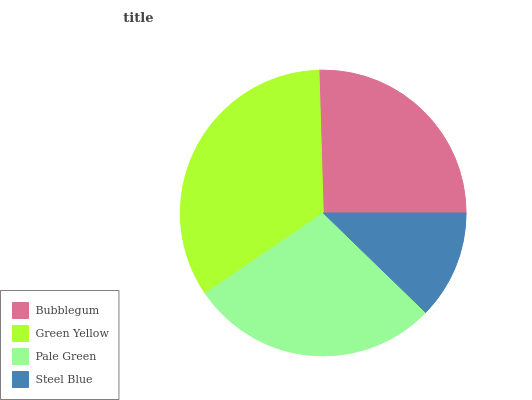Is Steel Blue the minimum?
Answer yes or no. Yes. Is Green Yellow the maximum?
Answer yes or no. Yes. Is Pale Green the minimum?
Answer yes or no. No. Is Pale Green the maximum?
Answer yes or no. No. Is Green Yellow greater than Pale Green?
Answer yes or no. Yes. Is Pale Green less than Green Yellow?
Answer yes or no. Yes. Is Pale Green greater than Green Yellow?
Answer yes or no. No. Is Green Yellow less than Pale Green?
Answer yes or no. No. Is Pale Green the high median?
Answer yes or no. Yes. Is Bubblegum the low median?
Answer yes or no. Yes. Is Steel Blue the high median?
Answer yes or no. No. Is Steel Blue the low median?
Answer yes or no. No. 